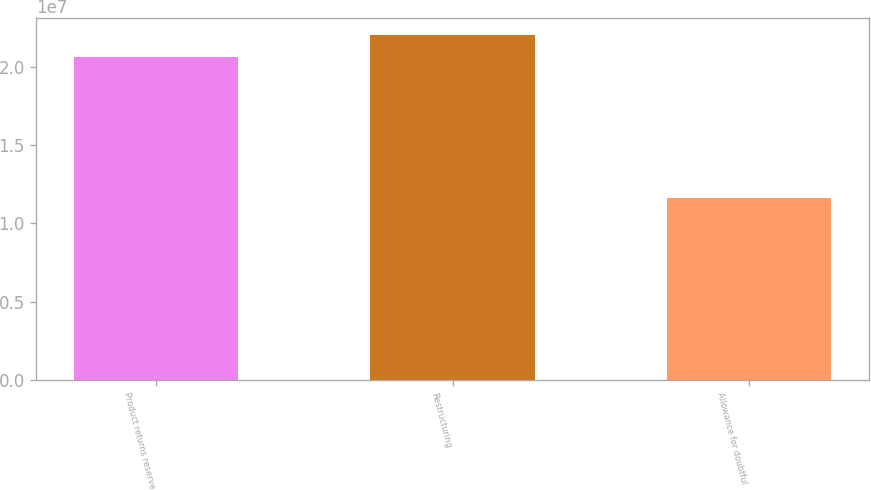Convert chart. <chart><loc_0><loc_0><loc_500><loc_500><bar_chart><fcel>Product returns reserve<fcel>Restructuring<fcel>Allowance for doubtful<nl><fcel>2.0578e+07<fcel>2.2002e+07<fcel>1.1611e+07<nl></chart> 